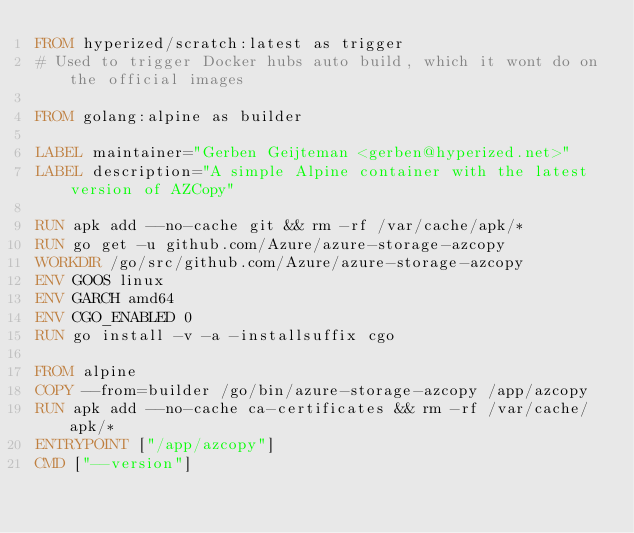<code> <loc_0><loc_0><loc_500><loc_500><_Dockerfile_>FROM hyperized/scratch:latest as trigger
# Used to trigger Docker hubs auto build, which it wont do on the official images

FROM golang:alpine as builder

LABEL maintainer="Gerben Geijteman <gerben@hyperized.net>"
LABEL description="A simple Alpine container with the latest version of AZCopy"

RUN apk add --no-cache git && rm -rf /var/cache/apk/*
RUN go get -u github.com/Azure/azure-storage-azcopy
WORKDIR /go/src/github.com/Azure/azure-storage-azcopy
ENV GOOS linux
ENV GARCH amd64
ENV CGO_ENABLED 0
RUN go install -v -a -installsuffix cgo

FROM alpine
COPY --from=builder /go/bin/azure-storage-azcopy /app/azcopy
RUN apk add --no-cache ca-certificates && rm -rf /var/cache/apk/*
ENTRYPOINT ["/app/azcopy"]
CMD ["--version"]
</code> 